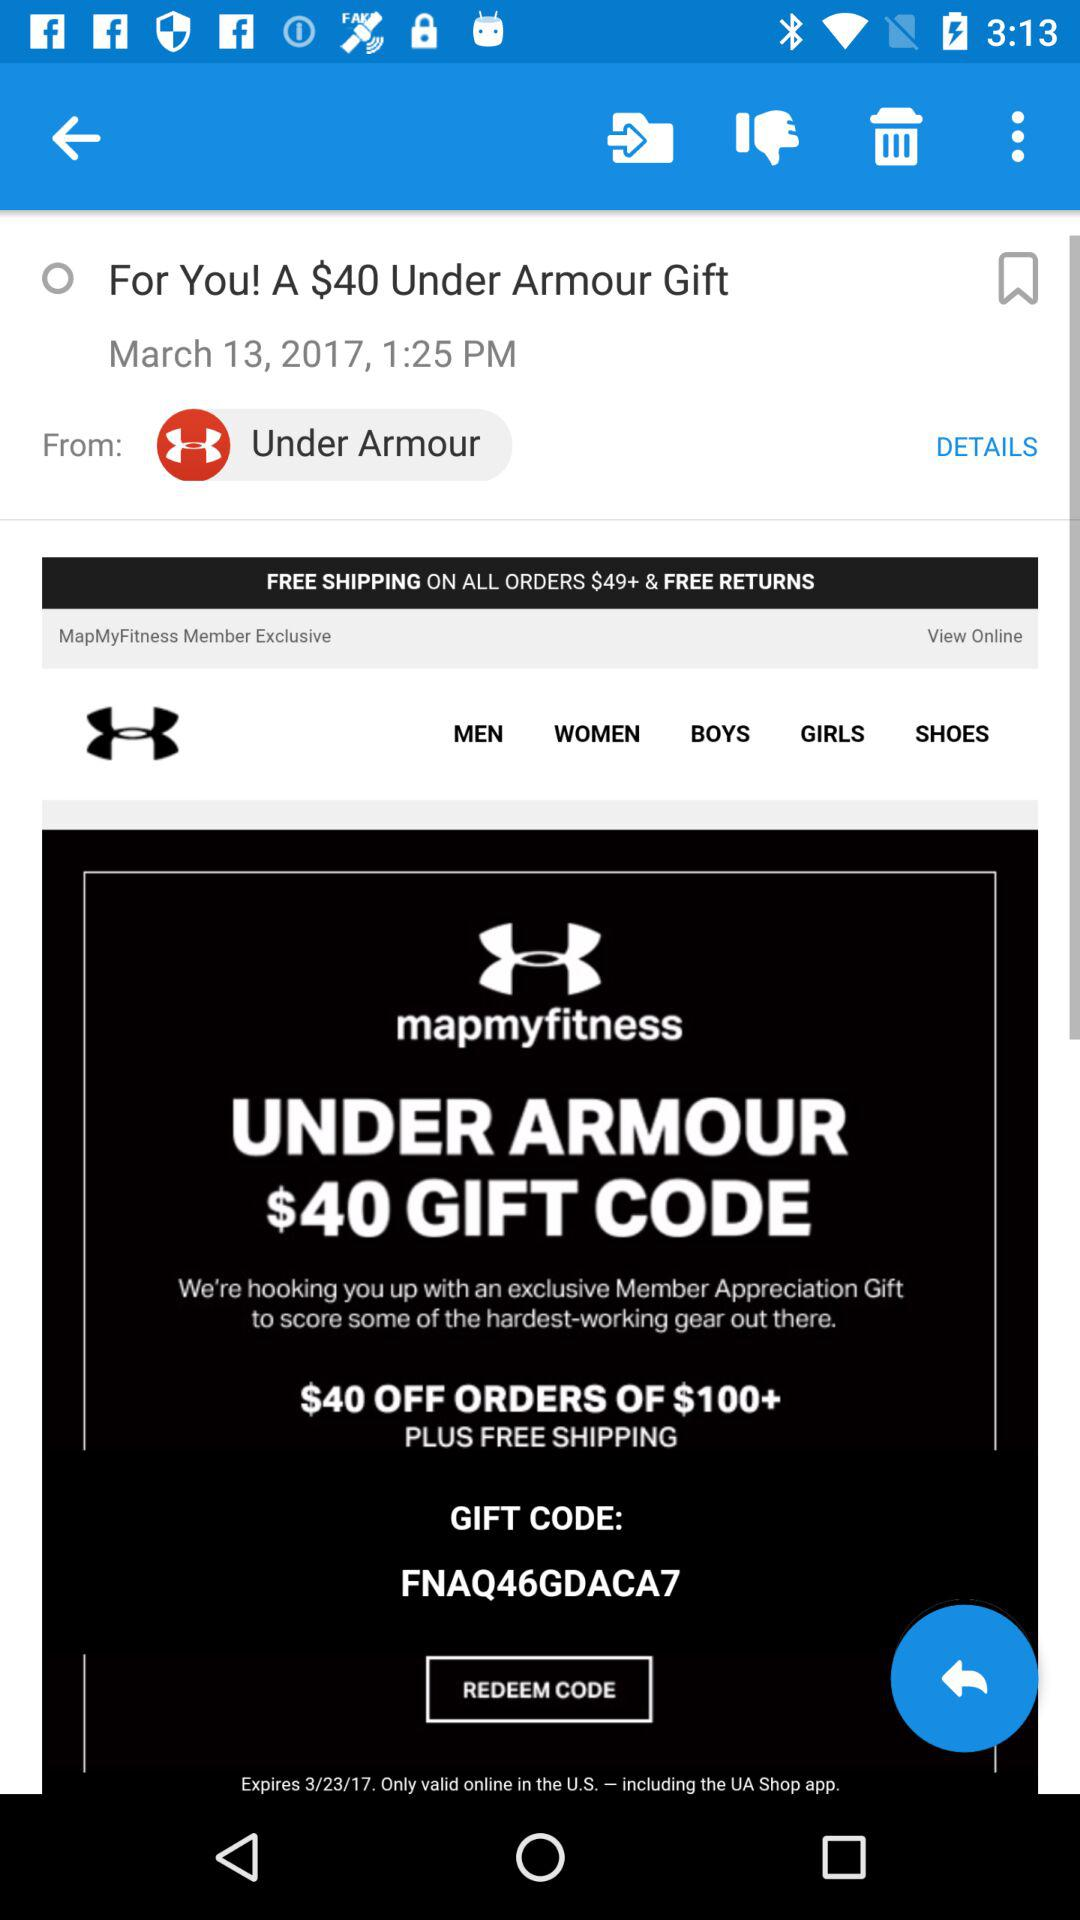What is the gift code? The gift code is FNAQ46GDACA7. 